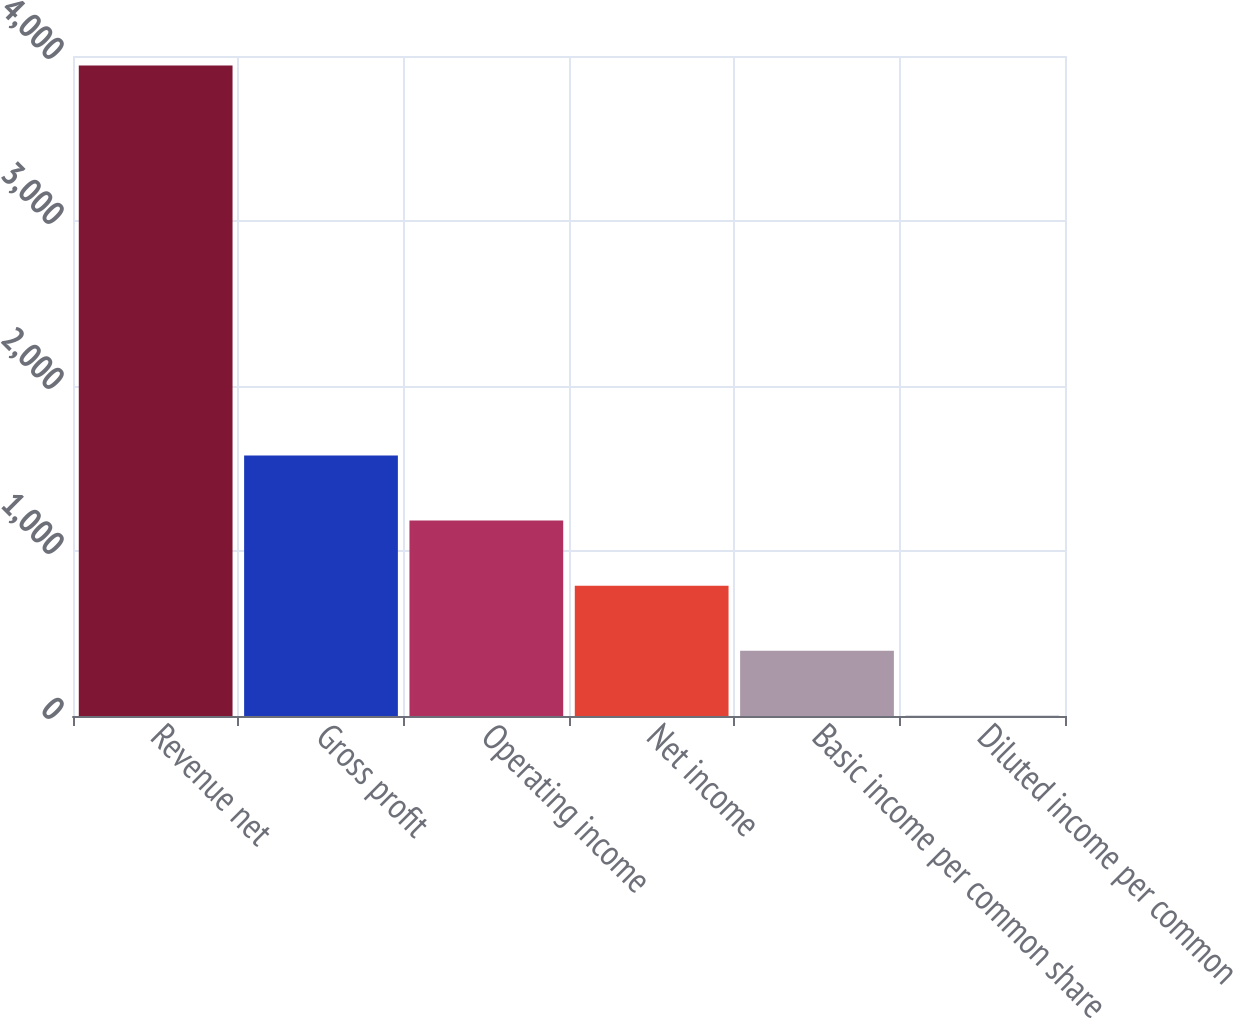Convert chart. <chart><loc_0><loc_0><loc_500><loc_500><bar_chart><fcel>Revenue net<fcel>Gross profit<fcel>Operating income<fcel>Net income<fcel>Basic income per common share<fcel>Diluted income per common<nl><fcel>3943<fcel>1578.24<fcel>1184.12<fcel>790<fcel>395.88<fcel>1.76<nl></chart> 